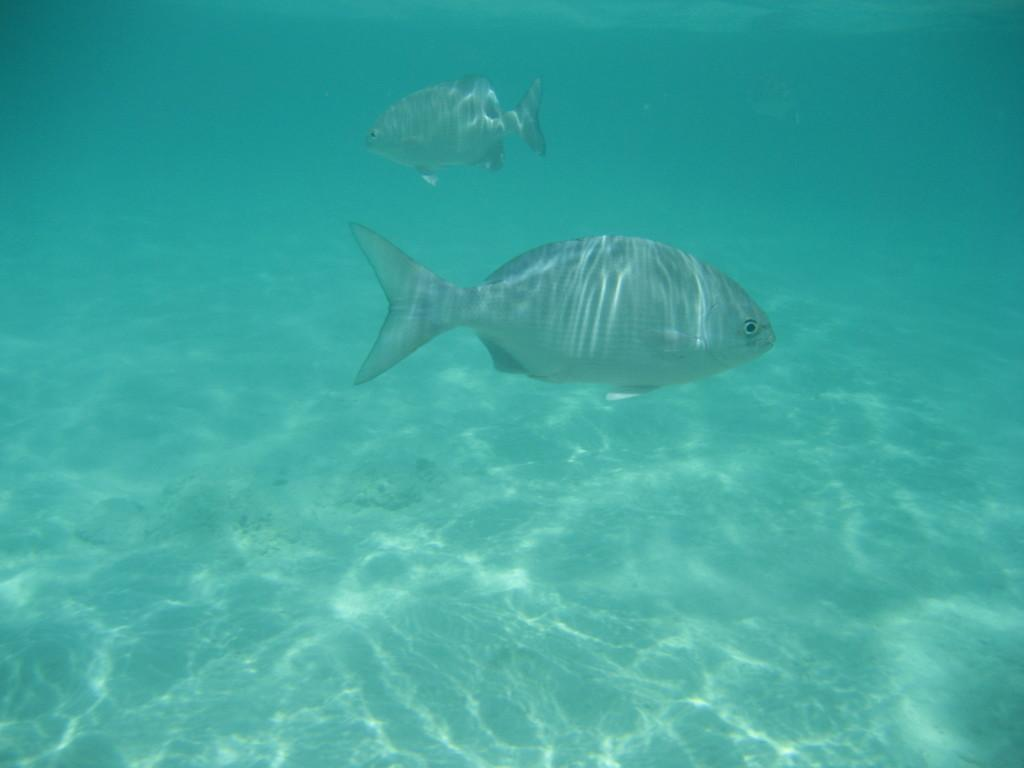What animals can be seen in the image? There are two fishes in the image. Where are the fishes located? The fishes are in the water. What type of engine is powering the fishes in the image? There is no engine present in the image, as the fishes are in the water and not mechanical objects. 